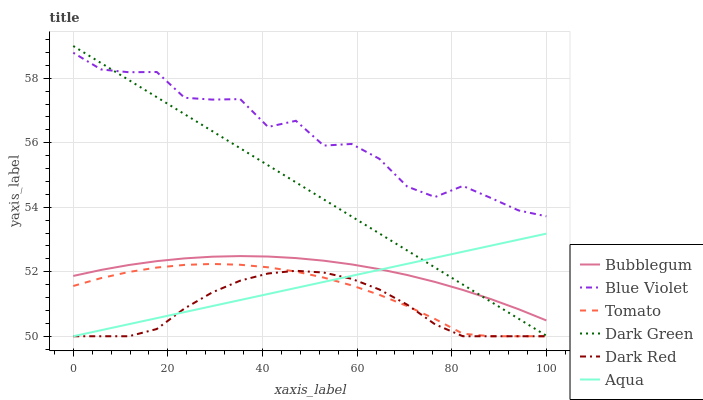Does Dark Red have the minimum area under the curve?
Answer yes or no. Yes. Does Blue Violet have the maximum area under the curve?
Answer yes or no. Yes. Does Aqua have the minimum area under the curve?
Answer yes or no. No. Does Aqua have the maximum area under the curve?
Answer yes or no. No. Is Aqua the smoothest?
Answer yes or no. Yes. Is Blue Violet the roughest?
Answer yes or no. Yes. Is Dark Red the smoothest?
Answer yes or no. No. Is Dark Red the roughest?
Answer yes or no. No. Does Tomato have the lowest value?
Answer yes or no. Yes. Does Bubblegum have the lowest value?
Answer yes or no. No. Does Dark Green have the highest value?
Answer yes or no. Yes. Does Aqua have the highest value?
Answer yes or no. No. Is Dark Red less than Blue Violet?
Answer yes or no. Yes. Is Blue Violet greater than Bubblegum?
Answer yes or no. Yes. Does Dark Green intersect Blue Violet?
Answer yes or no. Yes. Is Dark Green less than Blue Violet?
Answer yes or no. No. Is Dark Green greater than Blue Violet?
Answer yes or no. No. Does Dark Red intersect Blue Violet?
Answer yes or no. No. 